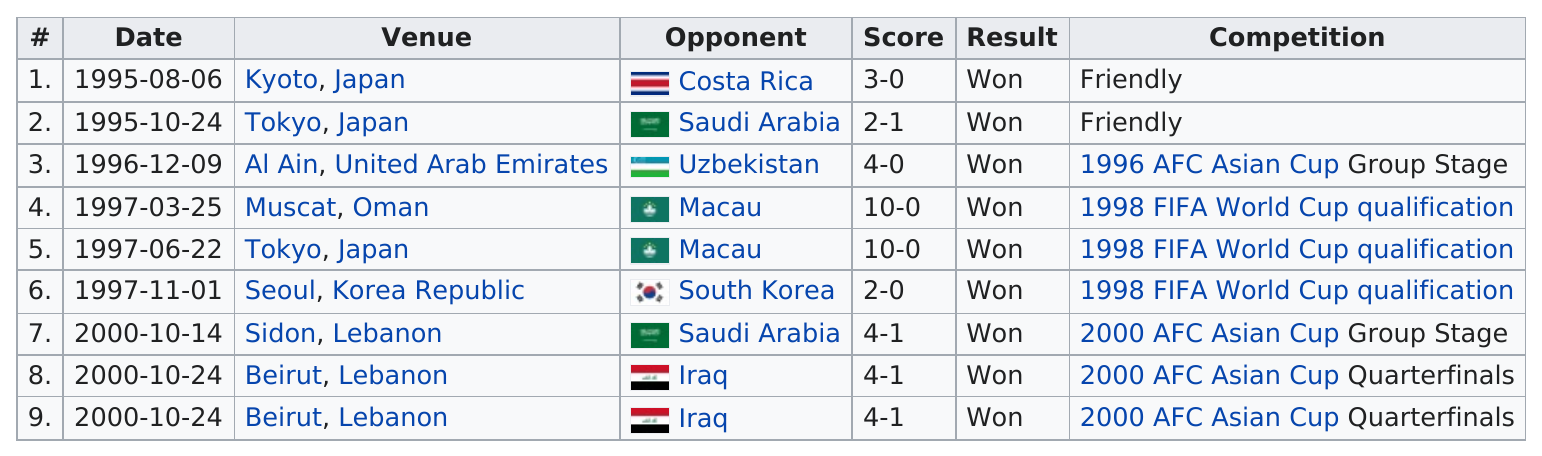List a handful of essential elements in this visual. In the venue located in Muscat, Oman, the score was the same as the 10-0 score that occurred in Tokyo, Japan. His first international goal was scored in the year 1995. In 2000, Saudi Arabia scored 1 point. The number of wins is 9. The winning team scored the least amount of points out of all the teams that played in the game. 